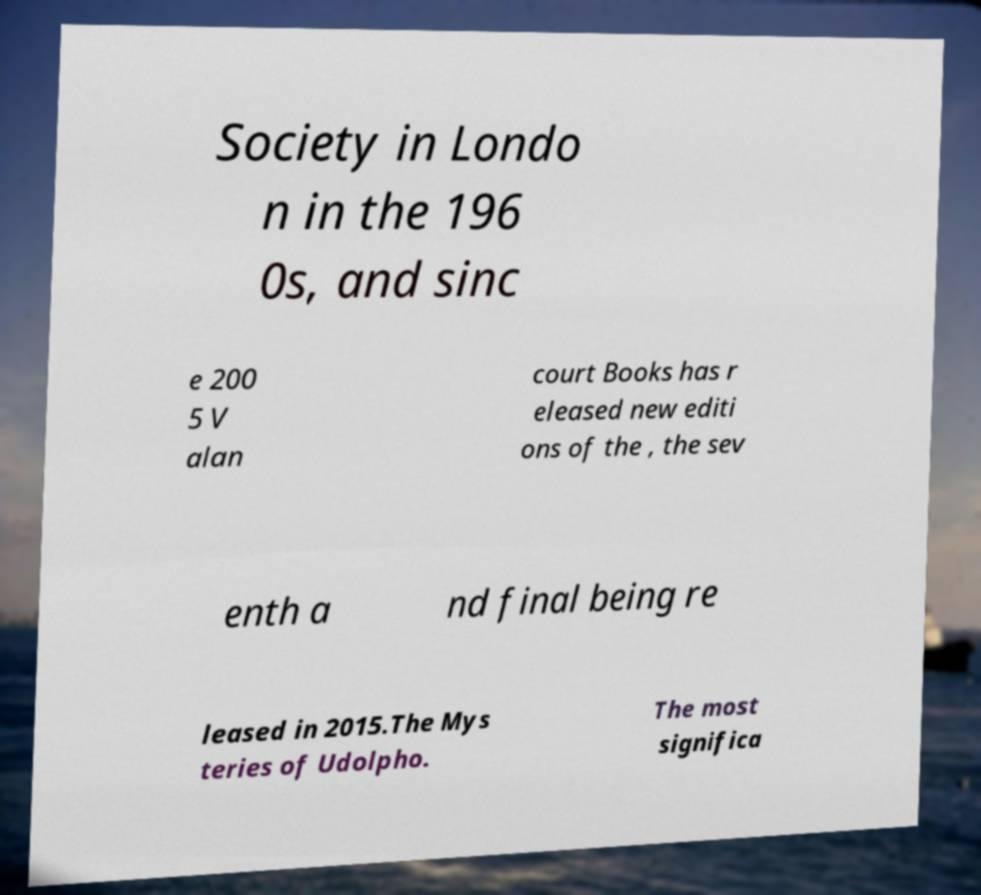Can you accurately transcribe the text from the provided image for me? Society in Londo n in the 196 0s, and sinc e 200 5 V alan court Books has r eleased new editi ons of the , the sev enth a nd final being re leased in 2015.The Mys teries of Udolpho. The most significa 